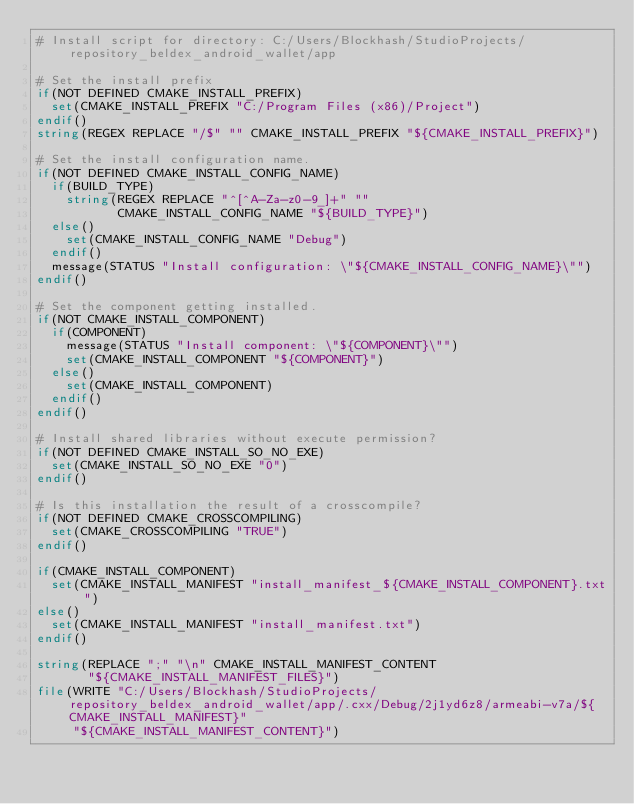<code> <loc_0><loc_0><loc_500><loc_500><_CMake_># Install script for directory: C:/Users/Blockhash/StudioProjects/repository_beldex_android_wallet/app

# Set the install prefix
if(NOT DEFINED CMAKE_INSTALL_PREFIX)
  set(CMAKE_INSTALL_PREFIX "C:/Program Files (x86)/Project")
endif()
string(REGEX REPLACE "/$" "" CMAKE_INSTALL_PREFIX "${CMAKE_INSTALL_PREFIX}")

# Set the install configuration name.
if(NOT DEFINED CMAKE_INSTALL_CONFIG_NAME)
  if(BUILD_TYPE)
    string(REGEX REPLACE "^[^A-Za-z0-9_]+" ""
           CMAKE_INSTALL_CONFIG_NAME "${BUILD_TYPE}")
  else()
    set(CMAKE_INSTALL_CONFIG_NAME "Debug")
  endif()
  message(STATUS "Install configuration: \"${CMAKE_INSTALL_CONFIG_NAME}\"")
endif()

# Set the component getting installed.
if(NOT CMAKE_INSTALL_COMPONENT)
  if(COMPONENT)
    message(STATUS "Install component: \"${COMPONENT}\"")
    set(CMAKE_INSTALL_COMPONENT "${COMPONENT}")
  else()
    set(CMAKE_INSTALL_COMPONENT)
  endif()
endif()

# Install shared libraries without execute permission?
if(NOT DEFINED CMAKE_INSTALL_SO_NO_EXE)
  set(CMAKE_INSTALL_SO_NO_EXE "0")
endif()

# Is this installation the result of a crosscompile?
if(NOT DEFINED CMAKE_CROSSCOMPILING)
  set(CMAKE_CROSSCOMPILING "TRUE")
endif()

if(CMAKE_INSTALL_COMPONENT)
  set(CMAKE_INSTALL_MANIFEST "install_manifest_${CMAKE_INSTALL_COMPONENT}.txt")
else()
  set(CMAKE_INSTALL_MANIFEST "install_manifest.txt")
endif()

string(REPLACE ";" "\n" CMAKE_INSTALL_MANIFEST_CONTENT
       "${CMAKE_INSTALL_MANIFEST_FILES}")
file(WRITE "C:/Users/Blockhash/StudioProjects/repository_beldex_android_wallet/app/.cxx/Debug/2j1yd6z8/armeabi-v7a/${CMAKE_INSTALL_MANIFEST}"
     "${CMAKE_INSTALL_MANIFEST_CONTENT}")
</code> 